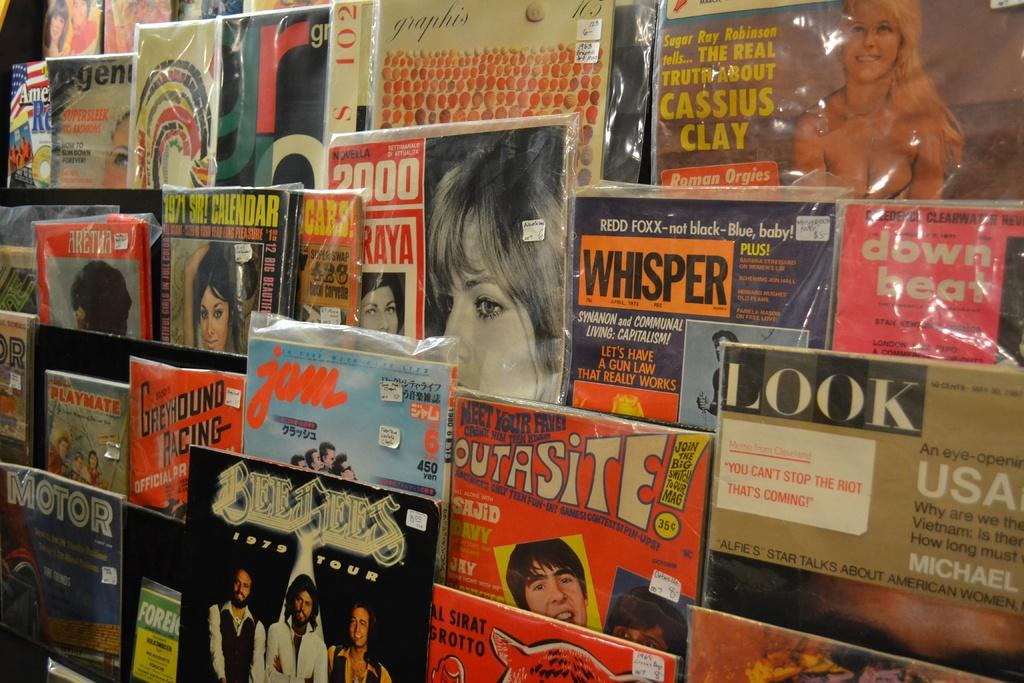<image>
Present a compact description of the photo's key features. Greyhound Racing Magazine and Look Magazine from the USA> 